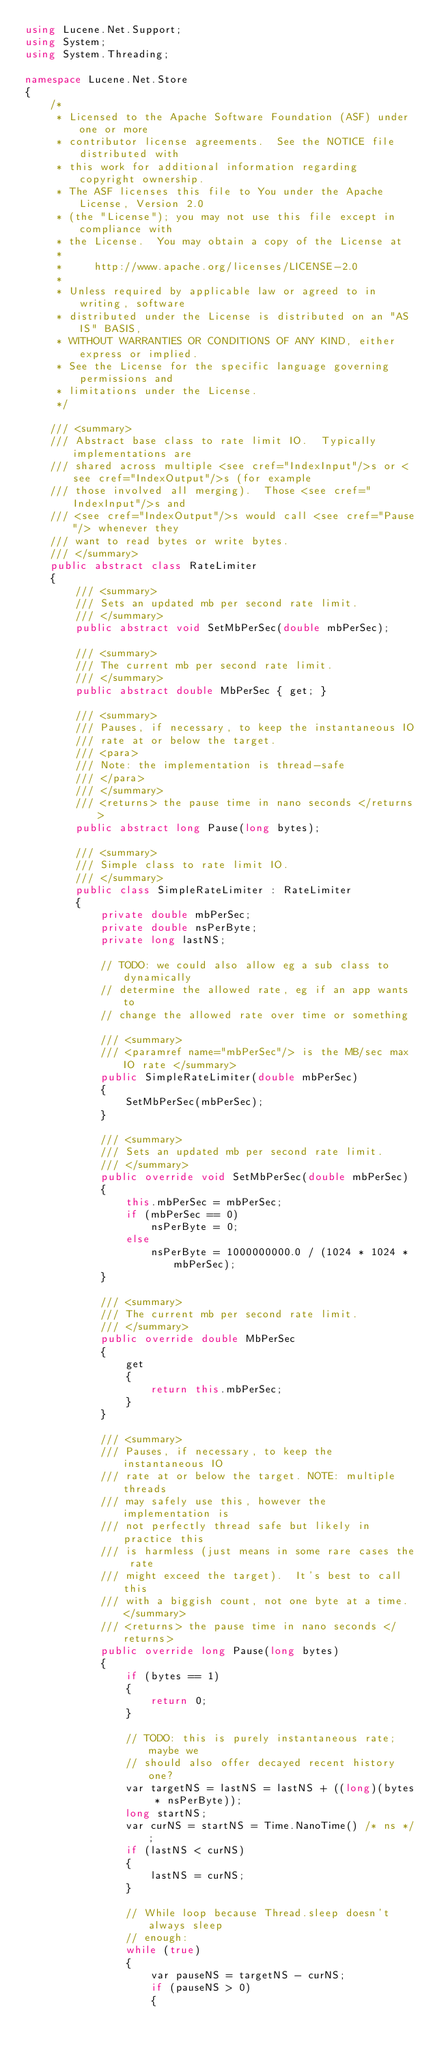Convert code to text. <code><loc_0><loc_0><loc_500><loc_500><_C#_>using Lucene.Net.Support;
using System;
using System.Threading;

namespace Lucene.Net.Store
{
    /*
     * Licensed to the Apache Software Foundation (ASF) under one or more
     * contributor license agreements.  See the NOTICE file distributed with
     * this work for additional information regarding copyright ownership.
     * The ASF licenses this file to You under the Apache License, Version 2.0
     * (the "License"); you may not use this file except in compliance with
     * the License.  You may obtain a copy of the License at
     *
     *     http://www.apache.org/licenses/LICENSE-2.0
     *
     * Unless required by applicable law or agreed to in writing, software
     * distributed under the License is distributed on an "AS IS" BASIS,
     * WITHOUT WARRANTIES OR CONDITIONS OF ANY KIND, either express or implied.
     * See the License for the specific language governing permissions and
     * limitations under the License.
     */

    /// <summary>
    /// Abstract base class to rate limit IO.  Typically implementations are
    /// shared across multiple <see cref="IndexInput"/>s or <see cref="IndexOutput"/>s (for example
    /// those involved all merging).  Those <see cref="IndexInput"/>s and
    /// <see cref="IndexOutput"/>s would call <see cref="Pause"/> whenever they
    /// want to read bytes or write bytes.
    /// </summary>
    public abstract class RateLimiter
    {
        /// <summary>
        /// Sets an updated mb per second rate limit.
        /// </summary>
        public abstract void SetMbPerSec(double mbPerSec);

        /// <summary>
        /// The current mb per second rate limit.
        /// </summary>
        public abstract double MbPerSec { get; }

        /// <summary>
        /// Pauses, if necessary, to keep the instantaneous IO
        /// rate at or below the target.
        /// <para>
        /// Note: the implementation is thread-safe
        /// </para> 
        /// </summary>
        /// <returns> the pause time in nano seconds </returns>
        public abstract long Pause(long bytes);

        /// <summary>
        /// Simple class to rate limit IO.
        /// </summary>
        public class SimpleRateLimiter : RateLimiter
        {
            private double mbPerSec;
            private double nsPerByte;
            private long lastNS;

            // TODO: we could also allow eg a sub class to dynamically
            // determine the allowed rate, eg if an app wants to
            // change the allowed rate over time or something

            /// <summary>
            /// <paramref name="mbPerSec"/> is the MB/sec max IO rate </summary>
            public SimpleRateLimiter(double mbPerSec)
            {
                SetMbPerSec(mbPerSec);
            }

            /// <summary>
            /// Sets an updated mb per second rate limit.
            /// </summary>
            public override void SetMbPerSec(double mbPerSec)
            {
                this.mbPerSec = mbPerSec;
                if (mbPerSec == 0)
                    nsPerByte = 0;
                else
                    nsPerByte = 1000000000.0 / (1024 * 1024 * mbPerSec);
            }

            /// <summary>
            /// The current mb per second rate limit.
            /// </summary>
            public override double MbPerSec
            {
                get
                {
                    return this.mbPerSec;
                }
            }

            /// <summary>
            /// Pauses, if necessary, to keep the instantaneous IO
            /// rate at or below the target. NOTE: multiple threads
            /// may safely use this, however the implementation is
            /// not perfectly thread safe but likely in practice this
            /// is harmless (just means in some rare cases the rate
            /// might exceed the target).  It's best to call this
            /// with a biggish count, not one byte at a time. </summary>
            /// <returns> the pause time in nano seconds </returns>
            public override long Pause(long bytes)
            {
                if (bytes == 1)
                {
                    return 0;
                }

                // TODO: this is purely instantaneous rate; maybe we
                // should also offer decayed recent history one?
                var targetNS = lastNS = lastNS + ((long)(bytes * nsPerByte));
                long startNS;
                var curNS = startNS = Time.NanoTime() /* ns */;
                if (lastNS < curNS)
                {
                    lastNS = curNS;
                }

                // While loop because Thread.sleep doesn't always sleep
                // enough:
                while (true)
                {
                    var pauseNS = targetNS - curNS;
                    if (pauseNS > 0)
                    {</code> 